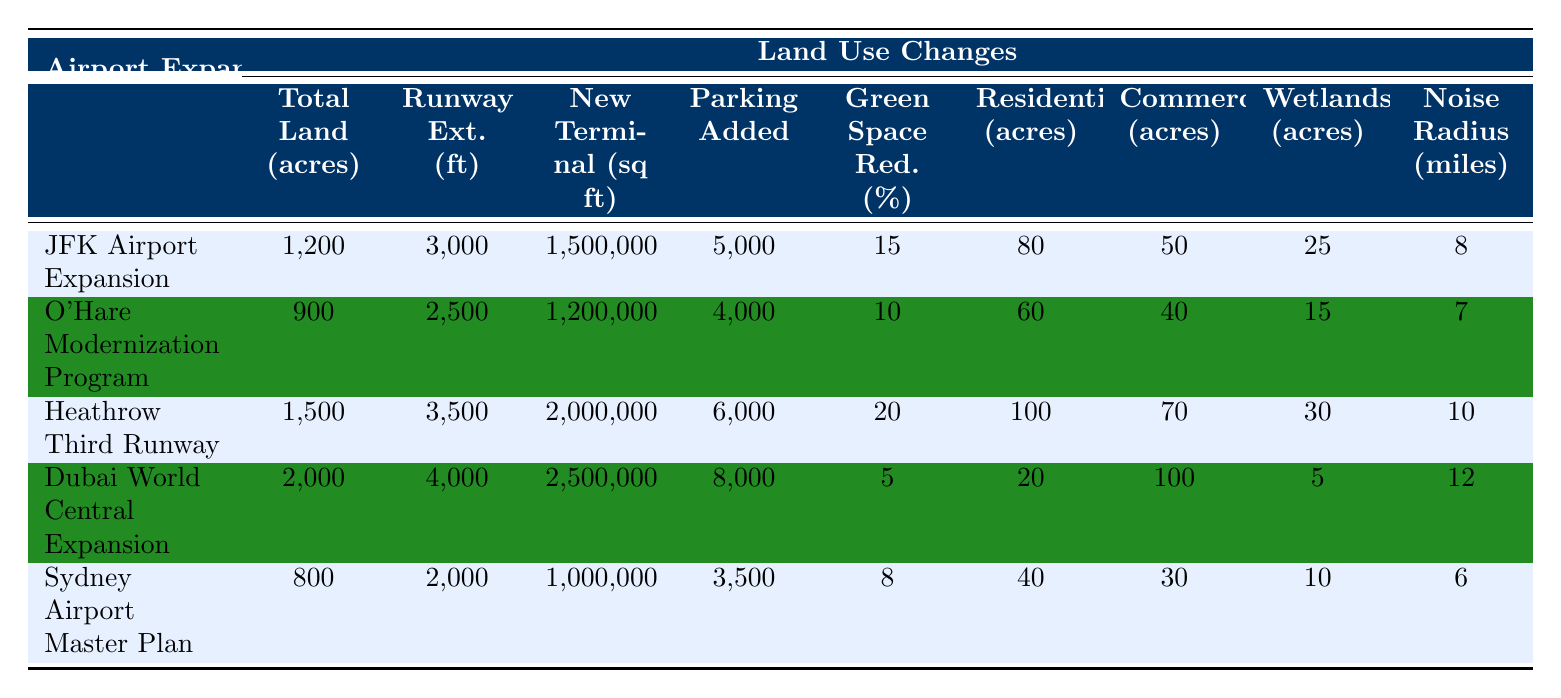What is the total land required for the Dubai World Central Expansion? The table shows that the total land required for the Dubai World Central Expansion is clearly stated as 2000 acres.
Answer: 2000 acres Which airport expansion plan has the greatest reduction in green space percentage? By comparing the "Green Space Reduction (%)" column, the Heathrow Third Runway has the highest reduction at 20%.
Answer: Heathrow Third Runway How many parking spaces will be added in total for the JFK Airport Expansion and O'Hare Modernization Program? For JFK Airport Expansion, 5000 parking spaces will be added, and for O'Hare Modernization Program, 4000 parking spaces will be added. Adding these two gives 5000 + 4000 = 9000.
Answer: 9000 Is the noise impact radius for the Sydney Airport Master Plan greater than that for the JFK Airport Expansion? The noise impact radius for Sydney Airport Master Plan is 6 miles and for JFK Airport Expansion, it is 8 miles. Since 6 is not greater than 8, the statement is false.
Answer: No What is the average number of residential acres affected across all expansion plans? The residential areas affected are 80, 60, 100, 20, and 40 acres for the respective plans. Summing them gives 80 + 60 + 100 + 20 + 40 = 300 acres. Dividing by 5 (the number of plans) provides an average of 300/5 = 60 acres.
Answer: 60 acres 